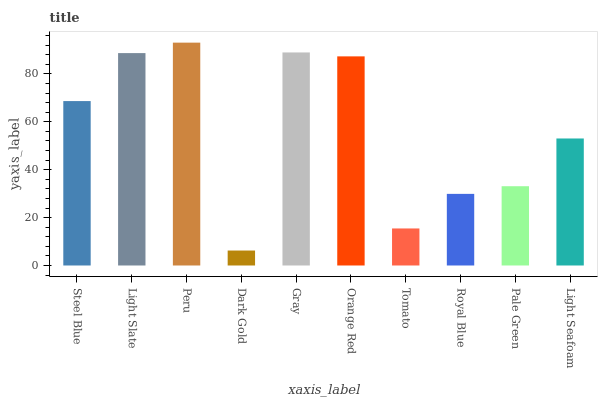Is Dark Gold the minimum?
Answer yes or no. Yes. Is Peru the maximum?
Answer yes or no. Yes. Is Light Slate the minimum?
Answer yes or no. No. Is Light Slate the maximum?
Answer yes or no. No. Is Light Slate greater than Steel Blue?
Answer yes or no. Yes. Is Steel Blue less than Light Slate?
Answer yes or no. Yes. Is Steel Blue greater than Light Slate?
Answer yes or no. No. Is Light Slate less than Steel Blue?
Answer yes or no. No. Is Steel Blue the high median?
Answer yes or no. Yes. Is Light Seafoam the low median?
Answer yes or no. Yes. Is Light Seafoam the high median?
Answer yes or no. No. Is Peru the low median?
Answer yes or no. No. 